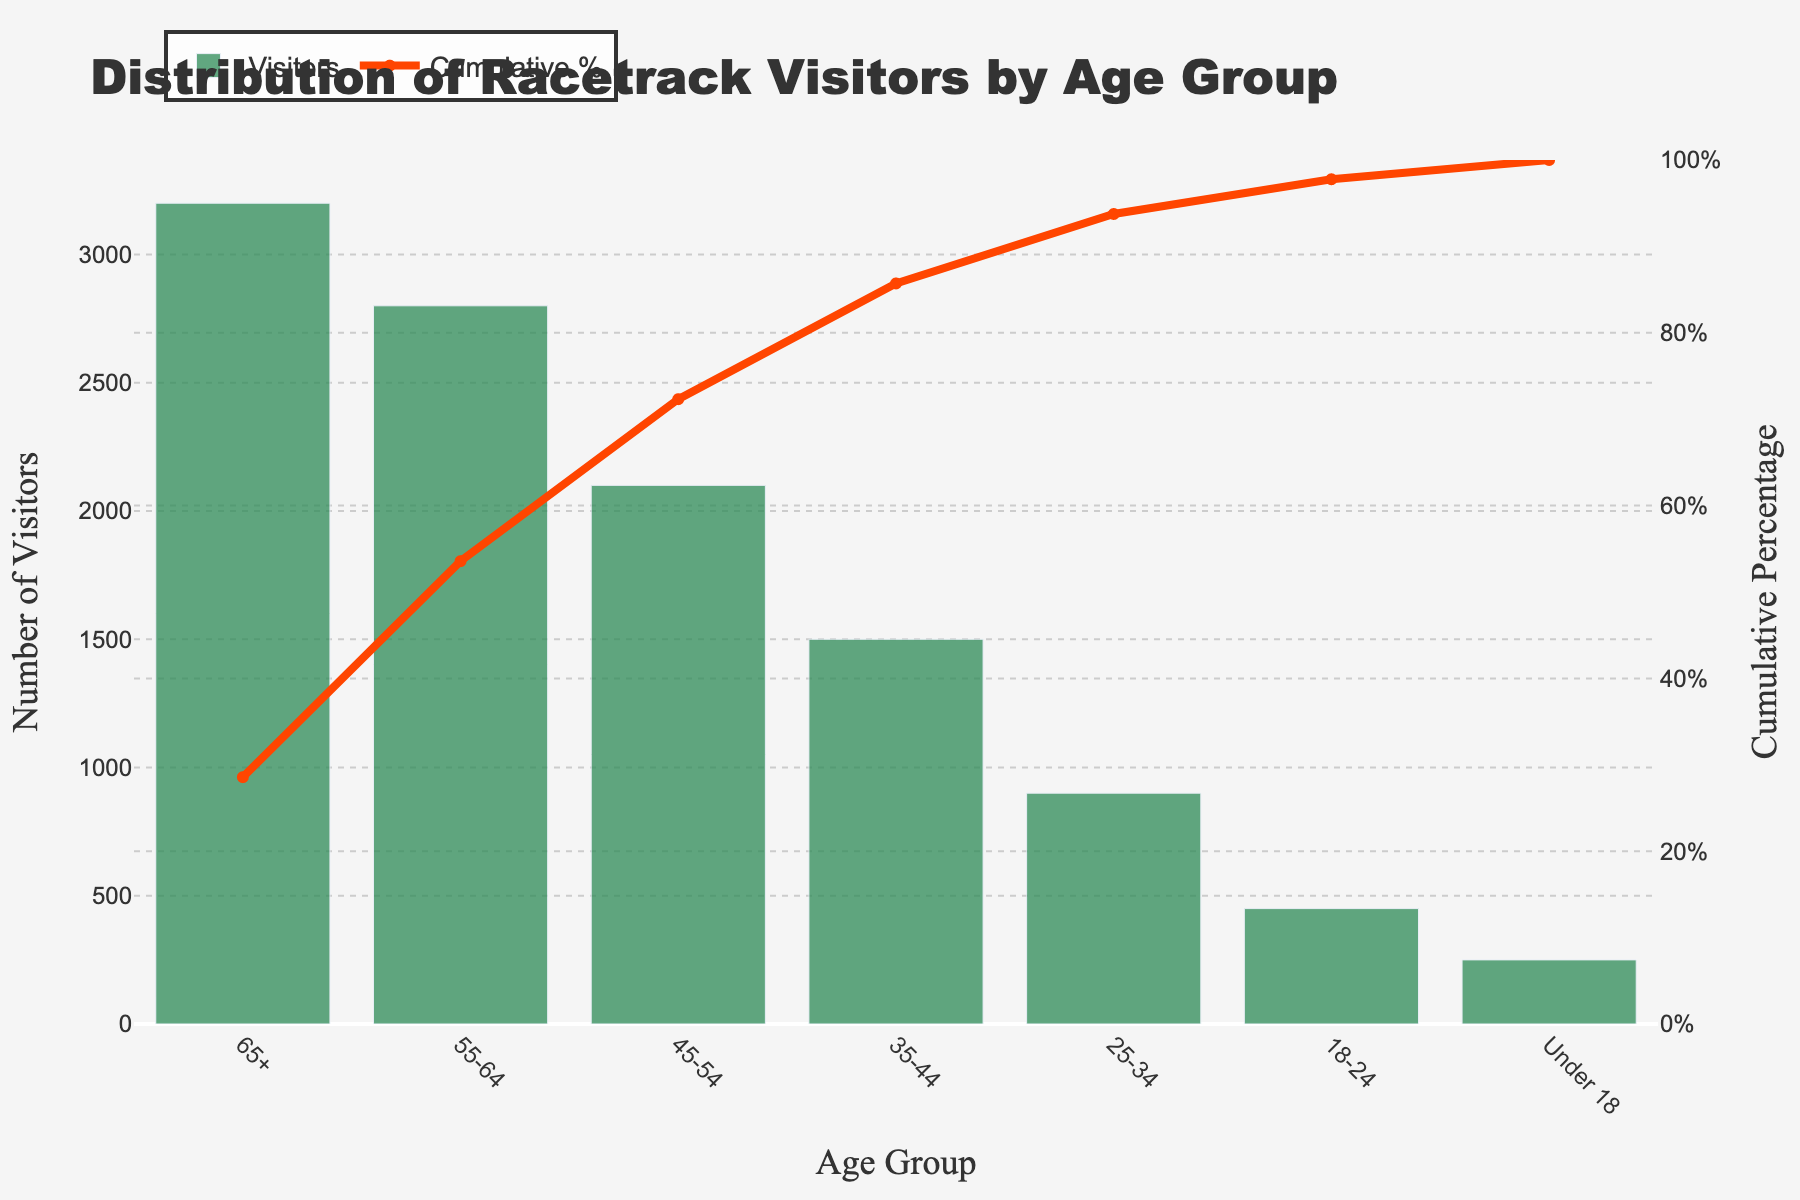What is the age group with the highest number of visitors? Refer to the highest bar in the figure, which represents the age group with the highest number of visitors. This is the 65+ age group.
Answer: 65+ What is the cumulative percentage of visitors for the age group 55-64? Refer to the line chart segment corresponding to the 55-64 age group and check its cumulative percentage.
Answer: 53.57% What is the difference in the number of visitors between the 55-64 age group and the 45-54 age group? Look at the heights of the bars for the 55-64 and 45-54 age groups and subtract the number of visitors for 45-54 from that of 55-64 (2800 - 2100).
Answer: 700 Which age group ranks third in terms of the number of visitors? Rank the age groups based on the height of the bars in descending order and identify the third bar. This is the 45-54 age group.
Answer: 45-54 How many visitors are covered by the cumulative percentage up to the 45-54 age group? Add the number of visitors for the 65+, 55-64, and 45-54 age groups. (3200 + 2800 + 2100)
Answer: 8100 Which age group contributes between 80% and 90% cumulative percentage? Check the age groups on the x-axis and the line chart showing cumulative percentages in the 80%-90% range. The 35-44 age group falls into this range.
Answer: 35-44 What is the cumulative percentage gap between the 65+ age group and the 25-34 age group? Subtract the cumulative percentage of the 25-34 age group from that of the 65+ age group (93.75% - 28.57%).
Answer: 65.18% Which age group has the least number of visitors? Identify the shortest bar, which represents the age group with the least number of visitors. This is the Under 18 age group.
Answer: Under 18 What is the cumulative percentage after the first three age groups? Refer to the cumulative percentage after the 65+, 55-64, and 45-54 age groups.
Answer: 72.32% How does the number of visitors in the 18-24 age group compare to the 35-44 age group? Compare the heights of the bars for the 18-24 and 35-44 age groups. The 35-44 age group has more visitors than the 18-24 age group.
Answer: 35-44 has more visitors 